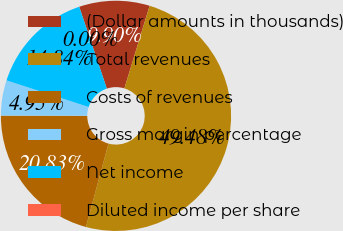<chart> <loc_0><loc_0><loc_500><loc_500><pie_chart><fcel>(Dollar amounts in thousands)<fcel>Total revenues<fcel>Costs of revenues<fcel>Gross margin percentage<fcel>Net income<fcel>Diluted income per share<nl><fcel>9.9%<fcel>49.48%<fcel>20.83%<fcel>4.95%<fcel>14.84%<fcel>0.0%<nl></chart> 